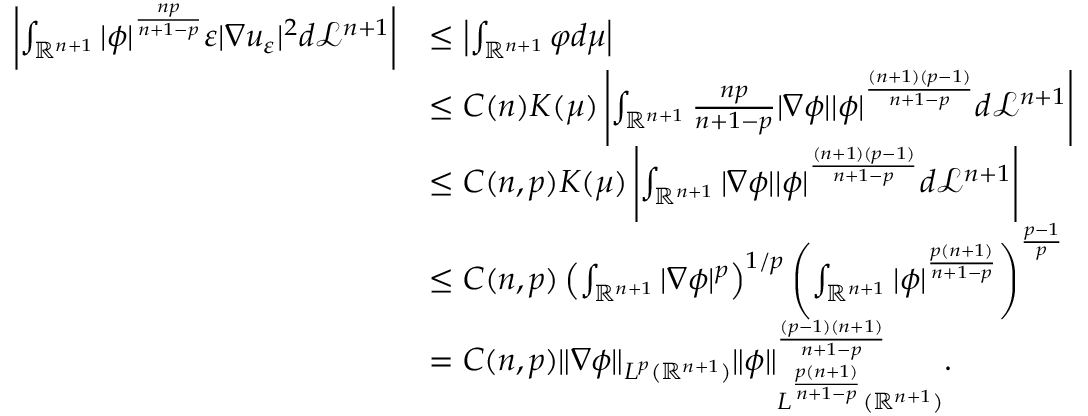Convert formula to latex. <formula><loc_0><loc_0><loc_500><loc_500>\begin{array} { r l } { \left | \int _ { \mathbb { R } ^ { n + 1 } } | \phi | ^ { \frac { n p } { n + 1 - p } } \varepsilon | \nabla u _ { \varepsilon } | ^ { 2 } d \mathcal { L } ^ { n + 1 } \right | } & { \leq \left | \int _ { \mathbb { R } ^ { n + 1 } } \varphi d \mu \right | } \\ & { \leq C ( n ) K ( \mu ) \left | \int _ { \mathbb { R } ^ { n + 1 } } \frac { n p } { n + 1 - p } | \nabla \phi | | \phi | ^ { \frac { ( n + 1 ) ( p - 1 ) } { n + 1 - p } } d \mathcal { L } ^ { n + 1 } \right | } \\ & { \leq C ( n , p ) K ( \mu ) \left | \int _ { \mathbb { R } ^ { n + 1 } } | \nabla \phi | | \phi | ^ { \frac { ( n + 1 ) ( p - 1 ) } { n + 1 - p } } d \mathcal { L } ^ { n + 1 } \right | } \\ & { \leq C ( n , p ) \left ( \int _ { \mathbb { R } ^ { n + 1 } } | \nabla \phi | ^ { p } \right ) ^ { 1 / p } \left ( \int _ { \mathbb { R } ^ { n + 1 } } | \phi | ^ { \frac { p ( n + 1 ) } { n + 1 - p } } \right ) ^ { \frac { p - 1 } { p } } } \\ & { = C ( n , p ) \| \nabla \phi \| _ { L ^ { p } ( \mathbb { R } ^ { n + 1 } ) } \| \phi \| _ { L ^ { \frac { p ( n + 1 ) } { n + 1 - p } } ( \mathbb { R } ^ { n + 1 } ) } ^ { \frac { ( p - 1 ) ( n + 1 ) } { n + 1 - p } } . } \end{array}</formula> 